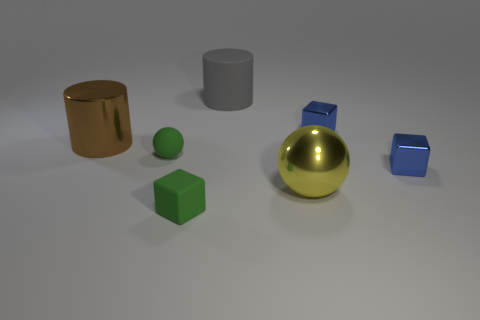Does the small ball have the same color as the tiny matte block?
Offer a terse response. Yes. There is a blue shiny thing that is in front of the green rubber thing behind the big yellow metal object; what is its shape?
Make the answer very short. Cube. Is the number of small metallic things less than the number of gray matte things?
Keep it short and to the point. No. What size is the object that is both on the left side of the big ball and behind the brown shiny thing?
Your answer should be very brief. Large. Is the size of the yellow object the same as the rubber ball?
Keep it short and to the point. No. Do the block to the left of the big matte cylinder and the matte sphere have the same color?
Ensure brevity in your answer.  Yes. There is a brown thing; what number of spheres are behind it?
Give a very brief answer. 0. Is the number of big yellow metallic balls greater than the number of large cylinders?
Offer a very short reply. No. There is a tiny thing that is on the right side of the green matte ball and to the left of the big gray object; what shape is it?
Make the answer very short. Cube. Are any cyan shiny blocks visible?
Offer a very short reply. No. 